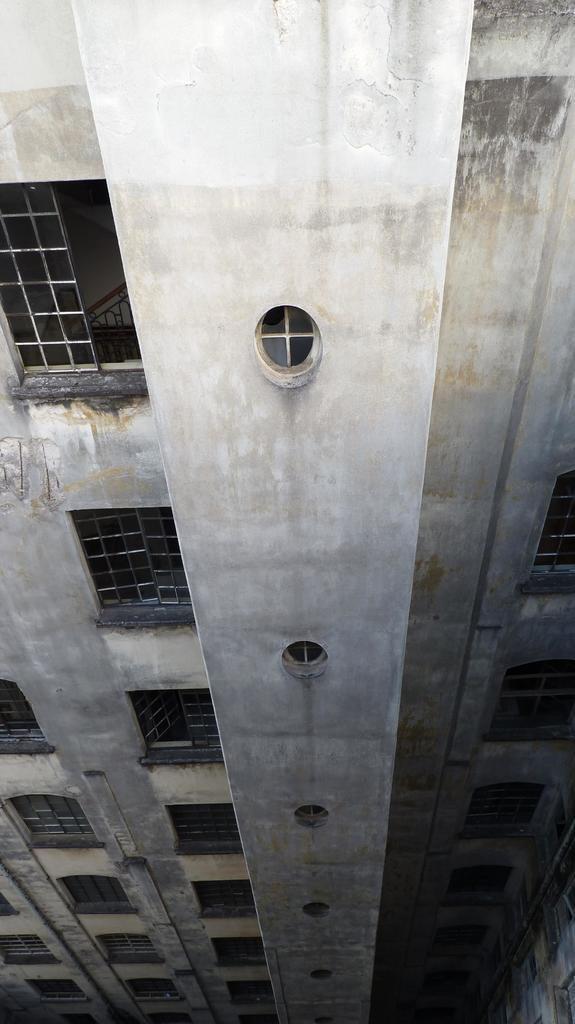How would you summarize this image in a sentence or two? In this picture we can see a building and few metal rods. 